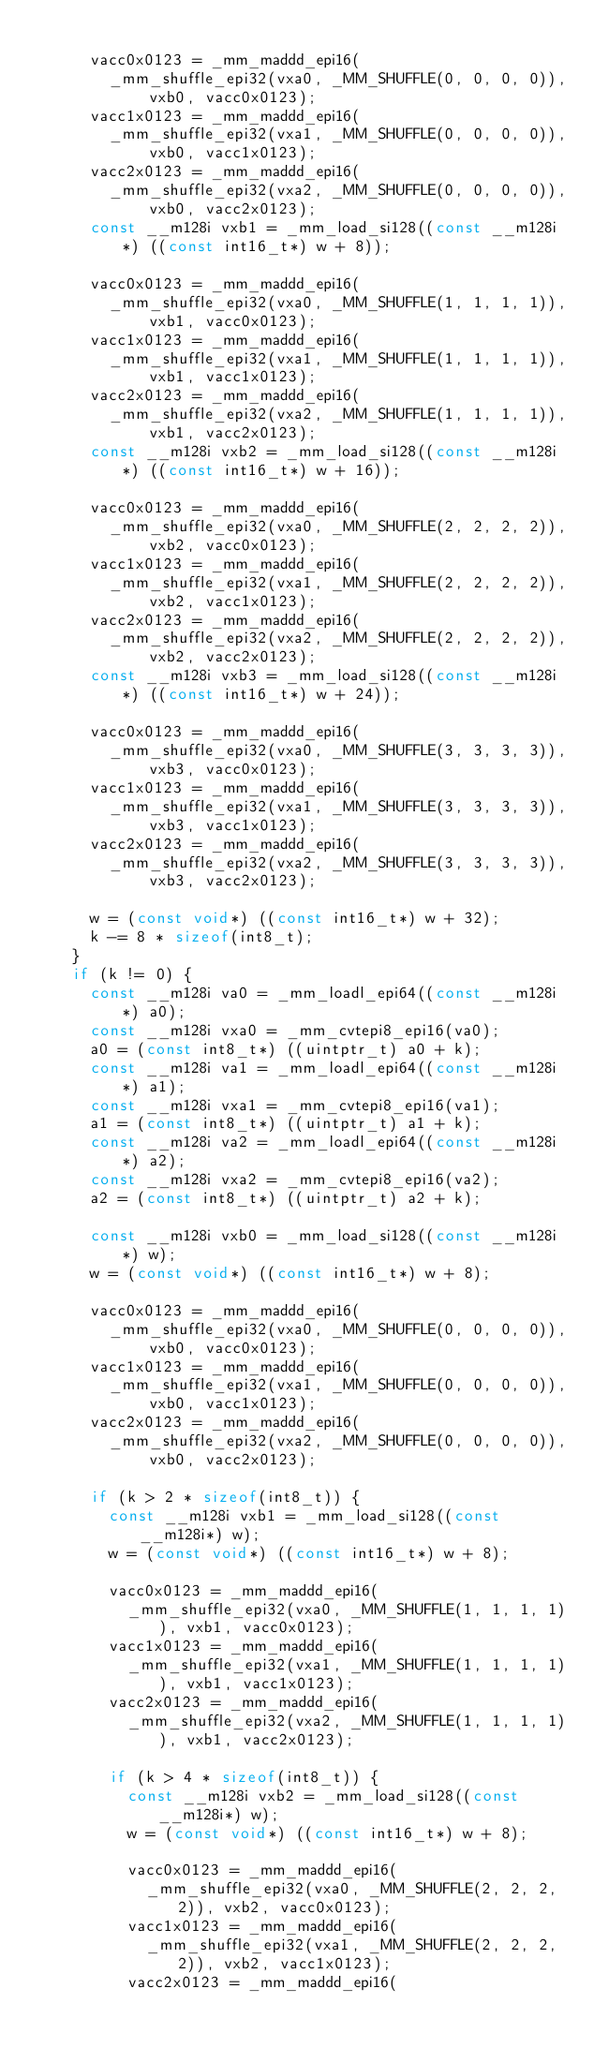Convert code to text. <code><loc_0><loc_0><loc_500><loc_500><_C_>
      vacc0x0123 = _mm_maddd_epi16(
        _mm_shuffle_epi32(vxa0, _MM_SHUFFLE(0, 0, 0, 0)), vxb0, vacc0x0123);
      vacc1x0123 = _mm_maddd_epi16(
        _mm_shuffle_epi32(vxa1, _MM_SHUFFLE(0, 0, 0, 0)), vxb0, vacc1x0123);
      vacc2x0123 = _mm_maddd_epi16(
        _mm_shuffle_epi32(vxa2, _MM_SHUFFLE(0, 0, 0, 0)), vxb0, vacc2x0123);
      const __m128i vxb1 = _mm_load_si128((const __m128i*) ((const int16_t*) w + 8));

      vacc0x0123 = _mm_maddd_epi16(
        _mm_shuffle_epi32(vxa0, _MM_SHUFFLE(1, 1, 1, 1)), vxb1, vacc0x0123);
      vacc1x0123 = _mm_maddd_epi16(
        _mm_shuffle_epi32(vxa1, _MM_SHUFFLE(1, 1, 1, 1)), vxb1, vacc1x0123);
      vacc2x0123 = _mm_maddd_epi16(
        _mm_shuffle_epi32(vxa2, _MM_SHUFFLE(1, 1, 1, 1)), vxb1, vacc2x0123);
      const __m128i vxb2 = _mm_load_si128((const __m128i*) ((const int16_t*) w + 16));

      vacc0x0123 = _mm_maddd_epi16(
        _mm_shuffle_epi32(vxa0, _MM_SHUFFLE(2, 2, 2, 2)), vxb2, vacc0x0123);
      vacc1x0123 = _mm_maddd_epi16(
        _mm_shuffle_epi32(vxa1, _MM_SHUFFLE(2, 2, 2, 2)), vxb2, vacc1x0123);
      vacc2x0123 = _mm_maddd_epi16(
        _mm_shuffle_epi32(vxa2, _MM_SHUFFLE(2, 2, 2, 2)), vxb2, vacc2x0123);
      const __m128i vxb3 = _mm_load_si128((const __m128i*) ((const int16_t*) w + 24));

      vacc0x0123 = _mm_maddd_epi16(
        _mm_shuffle_epi32(vxa0, _MM_SHUFFLE(3, 3, 3, 3)), vxb3, vacc0x0123);
      vacc1x0123 = _mm_maddd_epi16(
        _mm_shuffle_epi32(vxa1, _MM_SHUFFLE(3, 3, 3, 3)), vxb3, vacc1x0123);
      vacc2x0123 = _mm_maddd_epi16(
        _mm_shuffle_epi32(vxa2, _MM_SHUFFLE(3, 3, 3, 3)), vxb3, vacc2x0123);

      w = (const void*) ((const int16_t*) w + 32);
      k -= 8 * sizeof(int8_t);
    }
    if (k != 0) {
      const __m128i va0 = _mm_loadl_epi64((const __m128i*) a0);
      const __m128i vxa0 = _mm_cvtepi8_epi16(va0);
      a0 = (const int8_t*) ((uintptr_t) a0 + k);
      const __m128i va1 = _mm_loadl_epi64((const __m128i*) a1);
      const __m128i vxa1 = _mm_cvtepi8_epi16(va1);
      a1 = (const int8_t*) ((uintptr_t) a1 + k);
      const __m128i va2 = _mm_loadl_epi64((const __m128i*) a2);
      const __m128i vxa2 = _mm_cvtepi8_epi16(va2);
      a2 = (const int8_t*) ((uintptr_t) a2 + k);

      const __m128i vxb0 = _mm_load_si128((const __m128i*) w);
      w = (const void*) ((const int16_t*) w + 8);

      vacc0x0123 = _mm_maddd_epi16(
        _mm_shuffle_epi32(vxa0, _MM_SHUFFLE(0, 0, 0, 0)), vxb0, vacc0x0123);
      vacc1x0123 = _mm_maddd_epi16(
        _mm_shuffle_epi32(vxa1, _MM_SHUFFLE(0, 0, 0, 0)), vxb0, vacc1x0123);
      vacc2x0123 = _mm_maddd_epi16(
        _mm_shuffle_epi32(vxa2, _MM_SHUFFLE(0, 0, 0, 0)), vxb0, vacc2x0123);

      if (k > 2 * sizeof(int8_t)) {
        const __m128i vxb1 = _mm_load_si128((const __m128i*) w);
        w = (const void*) ((const int16_t*) w + 8);

        vacc0x0123 = _mm_maddd_epi16(
          _mm_shuffle_epi32(vxa0, _MM_SHUFFLE(1, 1, 1, 1)), vxb1, vacc0x0123);
        vacc1x0123 = _mm_maddd_epi16(
          _mm_shuffle_epi32(vxa1, _MM_SHUFFLE(1, 1, 1, 1)), vxb1, vacc1x0123);
        vacc2x0123 = _mm_maddd_epi16(
          _mm_shuffle_epi32(vxa2, _MM_SHUFFLE(1, 1, 1, 1)), vxb1, vacc2x0123);

        if (k > 4 * sizeof(int8_t)) {
          const __m128i vxb2 = _mm_load_si128((const __m128i*) w);
          w = (const void*) ((const int16_t*) w + 8);

          vacc0x0123 = _mm_maddd_epi16(
            _mm_shuffle_epi32(vxa0, _MM_SHUFFLE(2, 2, 2, 2)), vxb2, vacc0x0123);
          vacc1x0123 = _mm_maddd_epi16(
            _mm_shuffle_epi32(vxa1, _MM_SHUFFLE(2, 2, 2, 2)), vxb2, vacc1x0123);
          vacc2x0123 = _mm_maddd_epi16(</code> 